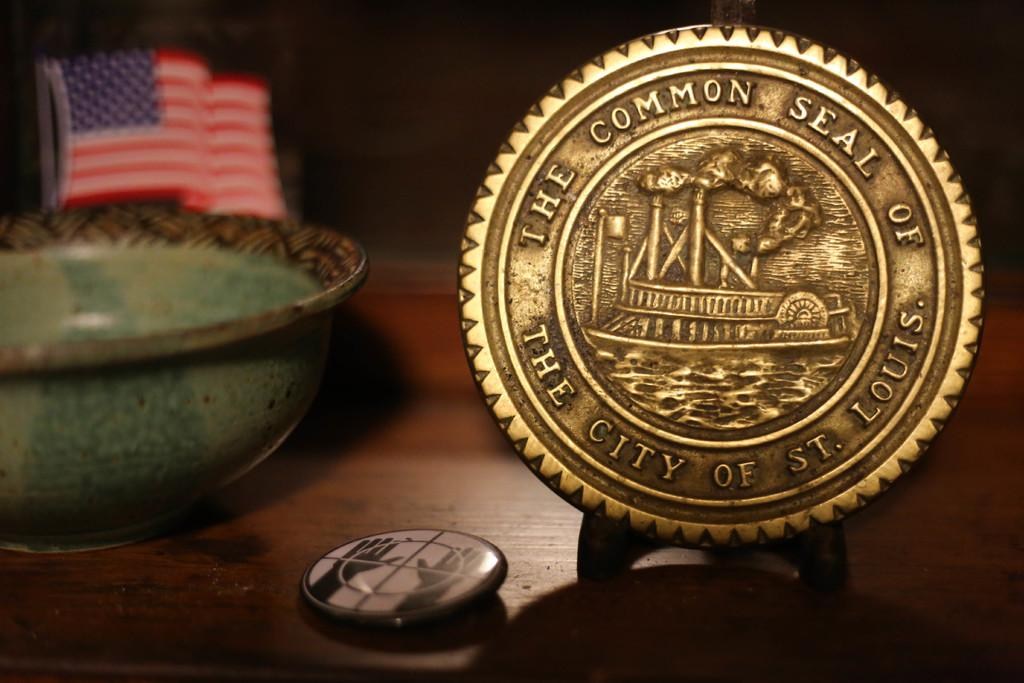What type of furniture is in the image? There is a table in the image. What animal is on the table? A seal is present on the table. What is on the table besides the seal? There is a bowl and a flag post on the table. What small object is on the table? A button is present on the table. What type of roof can be seen on the seal in the image? There is no roof present in the image, as the seal is not a building or structure with a roof. 